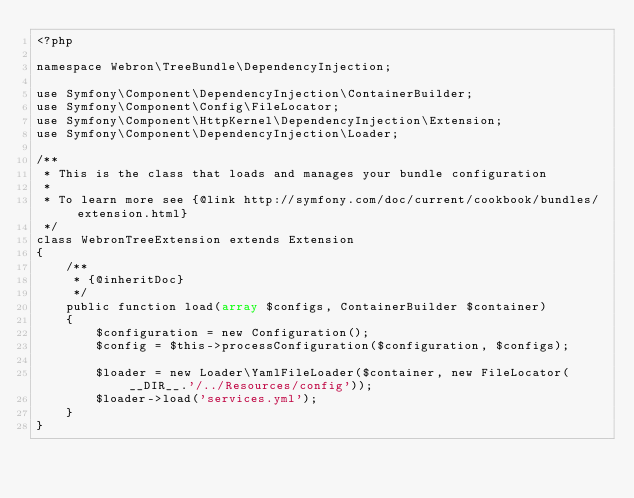Convert code to text. <code><loc_0><loc_0><loc_500><loc_500><_PHP_><?php

namespace Webron\TreeBundle\DependencyInjection;

use Symfony\Component\DependencyInjection\ContainerBuilder;
use Symfony\Component\Config\FileLocator;
use Symfony\Component\HttpKernel\DependencyInjection\Extension;
use Symfony\Component\DependencyInjection\Loader;

/**
 * This is the class that loads and manages your bundle configuration
 *
 * To learn more see {@link http://symfony.com/doc/current/cookbook/bundles/extension.html}
 */
class WebronTreeExtension extends Extension
{
    /**
     * {@inheritDoc}
     */
    public function load(array $configs, ContainerBuilder $container)
    {
        $configuration = new Configuration();
        $config = $this->processConfiguration($configuration, $configs);

        $loader = new Loader\YamlFileLoader($container, new FileLocator(__DIR__.'/../Resources/config'));
        $loader->load('services.yml');
    }
}
</code> 